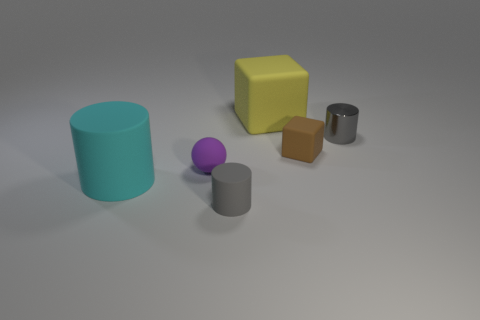Which objects look like they could hold water? The cyan and the grey cylinders are the only objects that appear to have the form of an open container that could potentially hold water. 